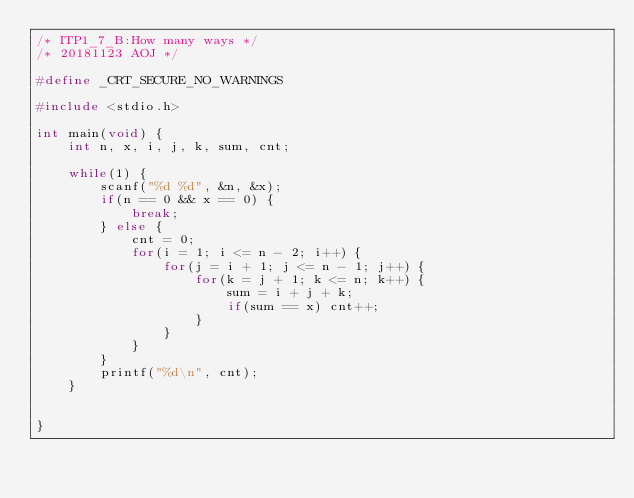<code> <loc_0><loc_0><loc_500><loc_500><_C_>/* ITP1_7_B:How many ways */
/* 20181123 AOJ */

#define _CRT_SECURE_NO_WARNINGS

#include <stdio.h>

int main(void) {
	int n, x, i, j, k, sum, cnt;

	while(1) {
		scanf("%d %d", &n, &x);
		if(n == 0 && x == 0) {
			break;
		} else {
			cnt = 0;
			for(i = 1; i <= n - 2; i++) {
				for(j = i + 1; j <= n - 1; j++) {
					for(k = j + 1; k <= n; k++) {
						sum = i + j + k;
						if(sum == x) cnt++;
					}
				}
			}
		}
		printf("%d\n", cnt);
	}

	
}
</code> 